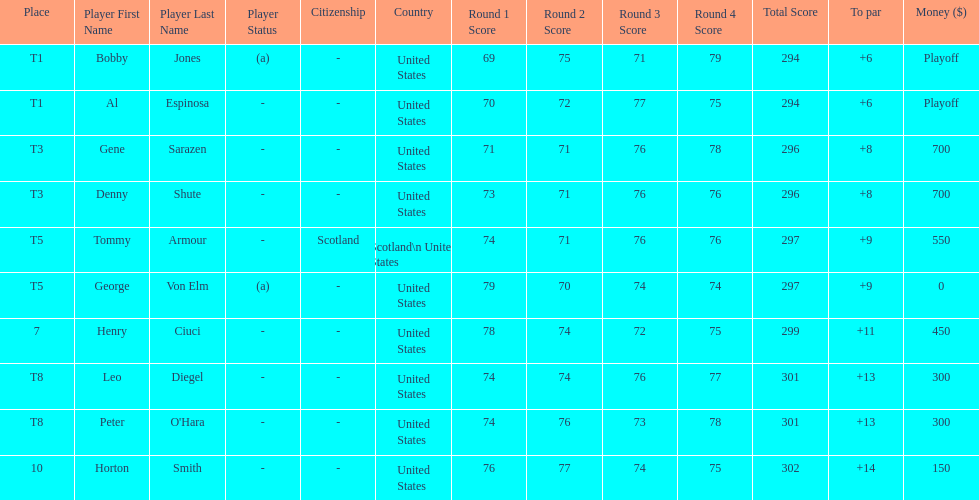Who finished next after bobby jones and al espinosa? Gene Sarazen, Denny Shute. 